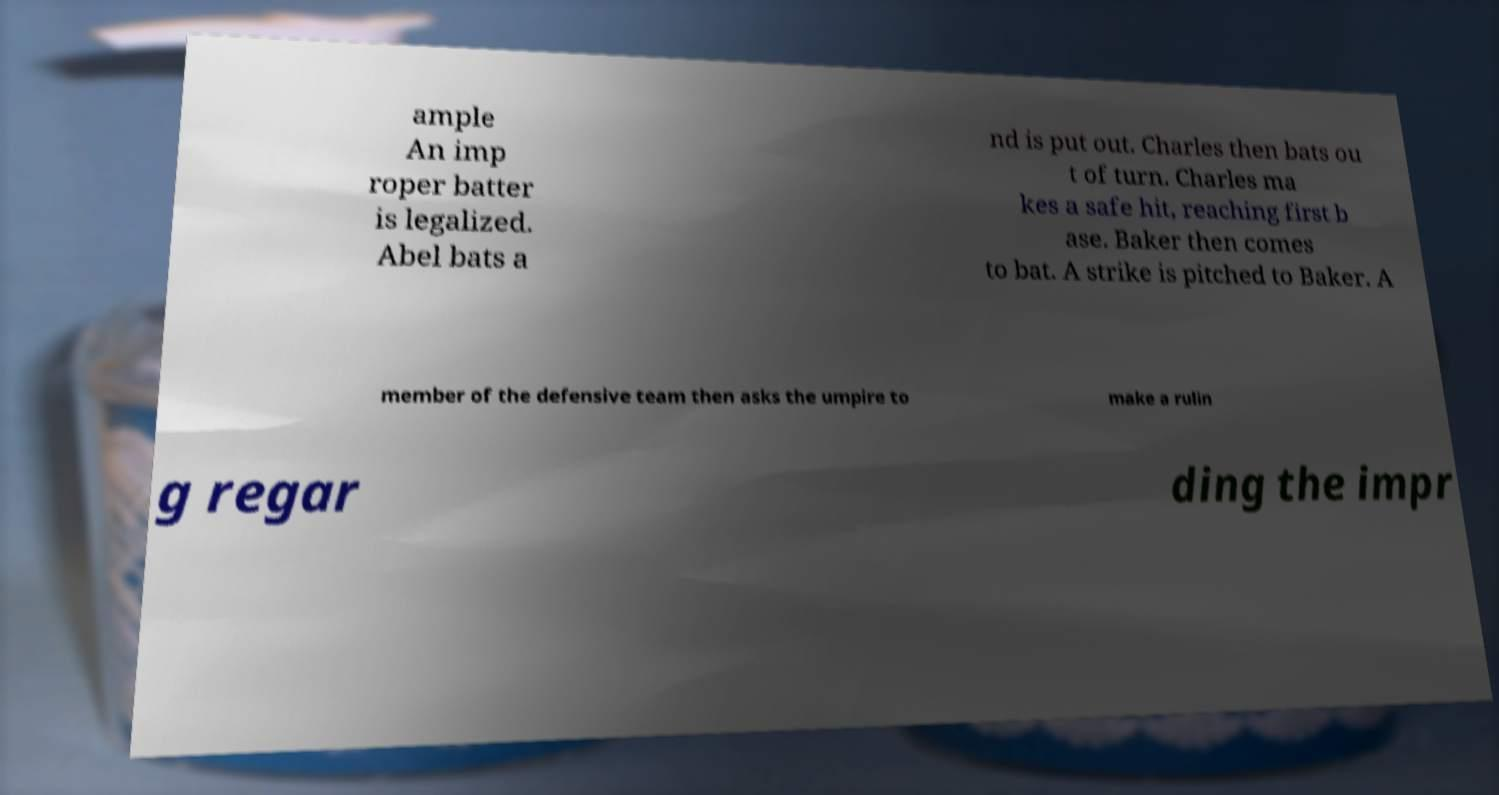Can you read and provide the text displayed in the image?This photo seems to have some interesting text. Can you extract and type it out for me? ample An imp roper batter is legalized. Abel bats a nd is put out. Charles then bats ou t of turn. Charles ma kes a safe hit, reaching first b ase. Baker then comes to bat. A strike is pitched to Baker. A member of the defensive team then asks the umpire to make a rulin g regar ding the impr 